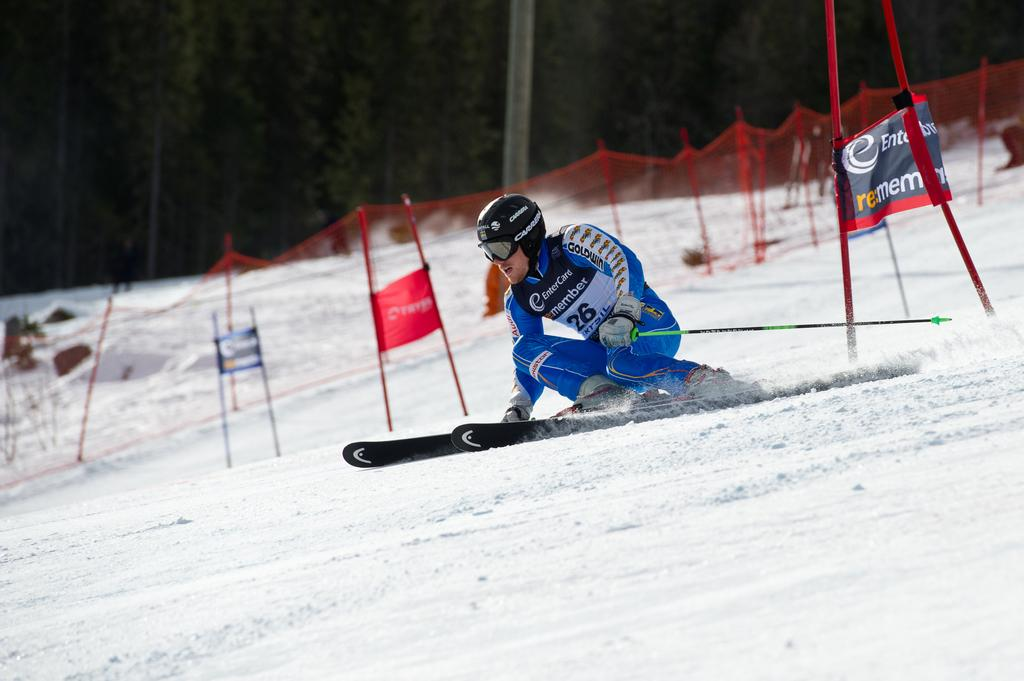What activity is the person in the image engaged in? The person is skiing in the image. What equipment is the person using for skiing? The person is using ski boards and holding a stick in their hand. What is the terrain like in the image? There is snow in the image, which suggests a winter or snowy environment. What can be seen in the background of the image? There is a fence, banners on stands, and trees in the background of the image. Where can the person be seen sleeping in the image? There is no indication of the person sleeping in the image; they are actively skiing. What type of alley can be seen in the image? There is no alley present in the image; it features a snowy landscape with a person skiing. 